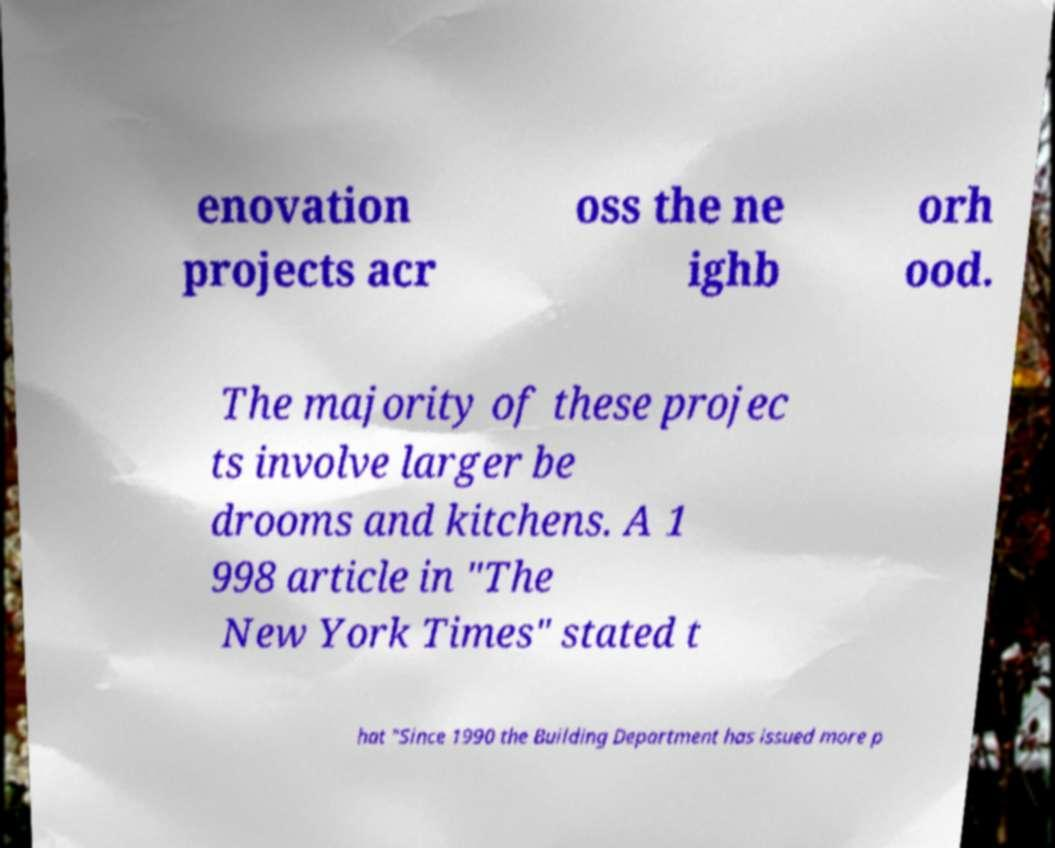What messages or text are displayed in this image? I need them in a readable, typed format. enovation projects acr oss the ne ighb orh ood. The majority of these projec ts involve larger be drooms and kitchens. A 1 998 article in "The New York Times" stated t hat "Since 1990 the Building Department has issued more p 